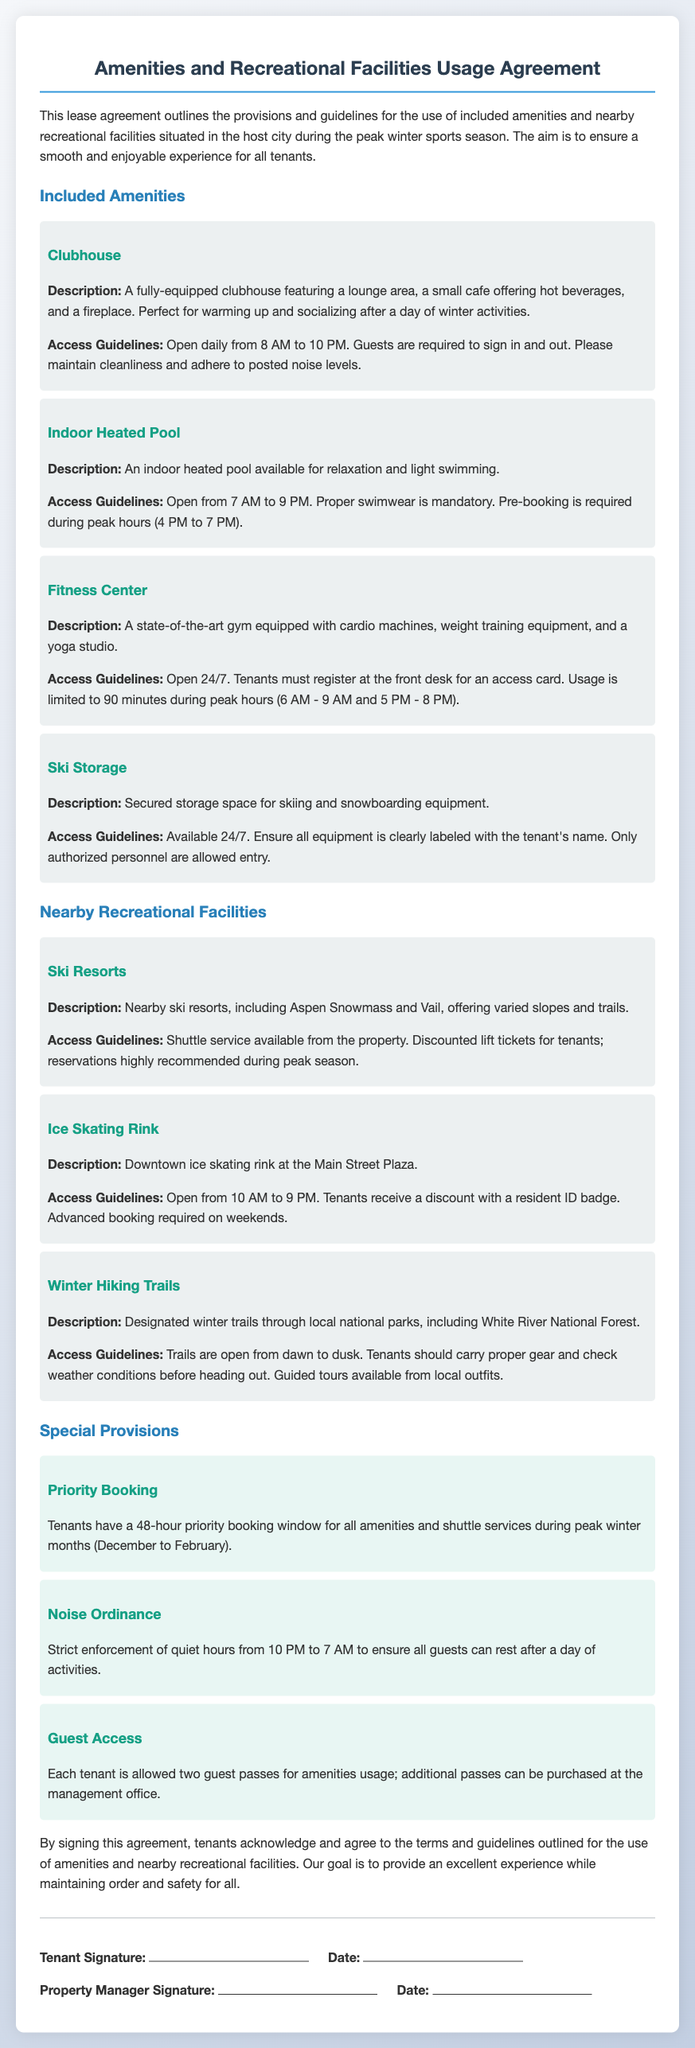What are the opening hours of the clubhouse? The document specifies that the clubhouse is open daily from 8 AM to 10 PM.
Answer: 8 AM to 10 PM What is the access guideline for the indoor heated pool during peak hours? The access guideline states that pre-booking is required during peak hours (4 PM to 7 PM).
Answer: Pre-booking required How many guest passes is each tenant allowed? The document states that each tenant is allowed two guest passes for amenities usage.
Answer: Two guest passes What is the noise ordinance time frame? The document mentions strict enforcement of quiet hours from 10 PM to 7 AM.
Answer: 10 PM to 7 AM What is the priority booking window for tenants? The document specifies that tenants have a 48-hour priority booking window during peak winter months.
Answer: 48 hours 